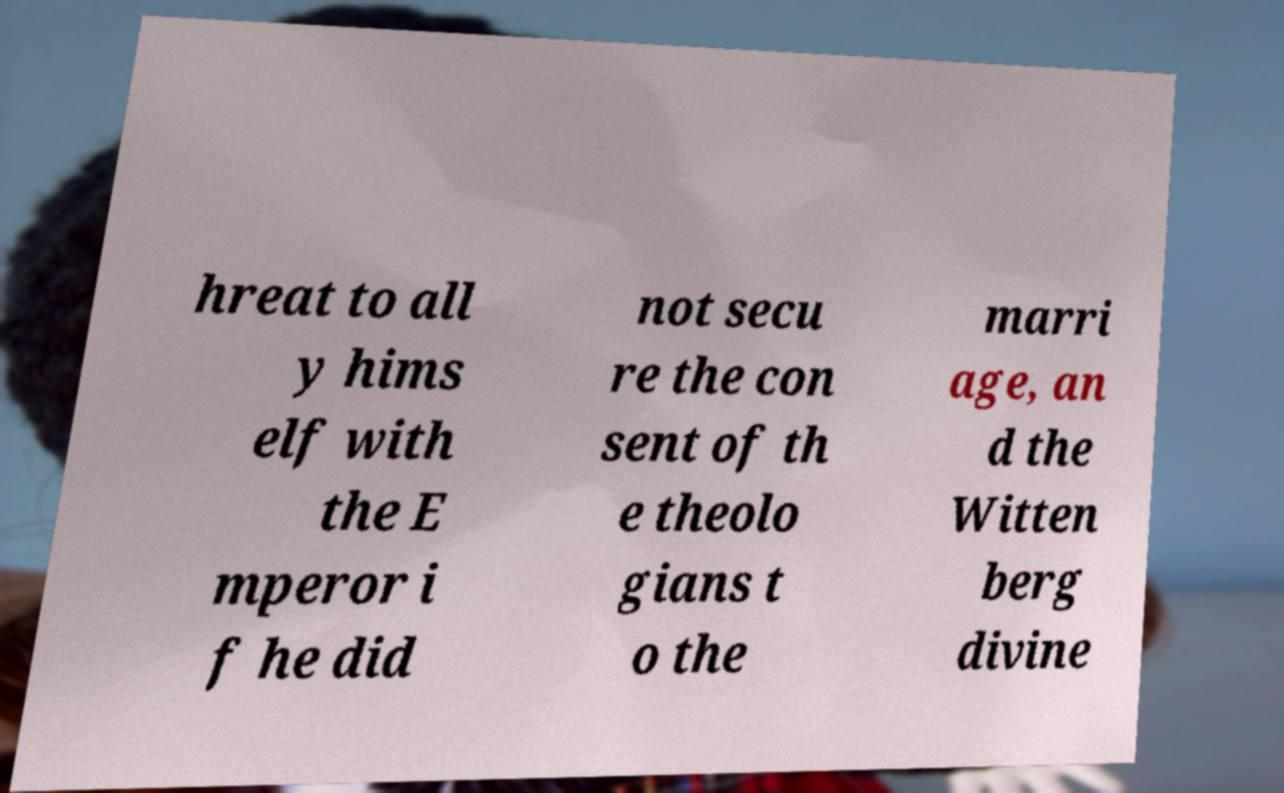Could you extract and type out the text from this image? hreat to all y hims elf with the E mperor i f he did not secu re the con sent of th e theolo gians t o the marri age, an d the Witten berg divine 